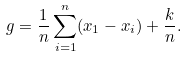<formula> <loc_0><loc_0><loc_500><loc_500>g = \frac { 1 } { n } \sum _ { i = 1 } ^ { n } ( x _ { 1 } - x _ { i } ) + \frac { k } { n } .</formula> 